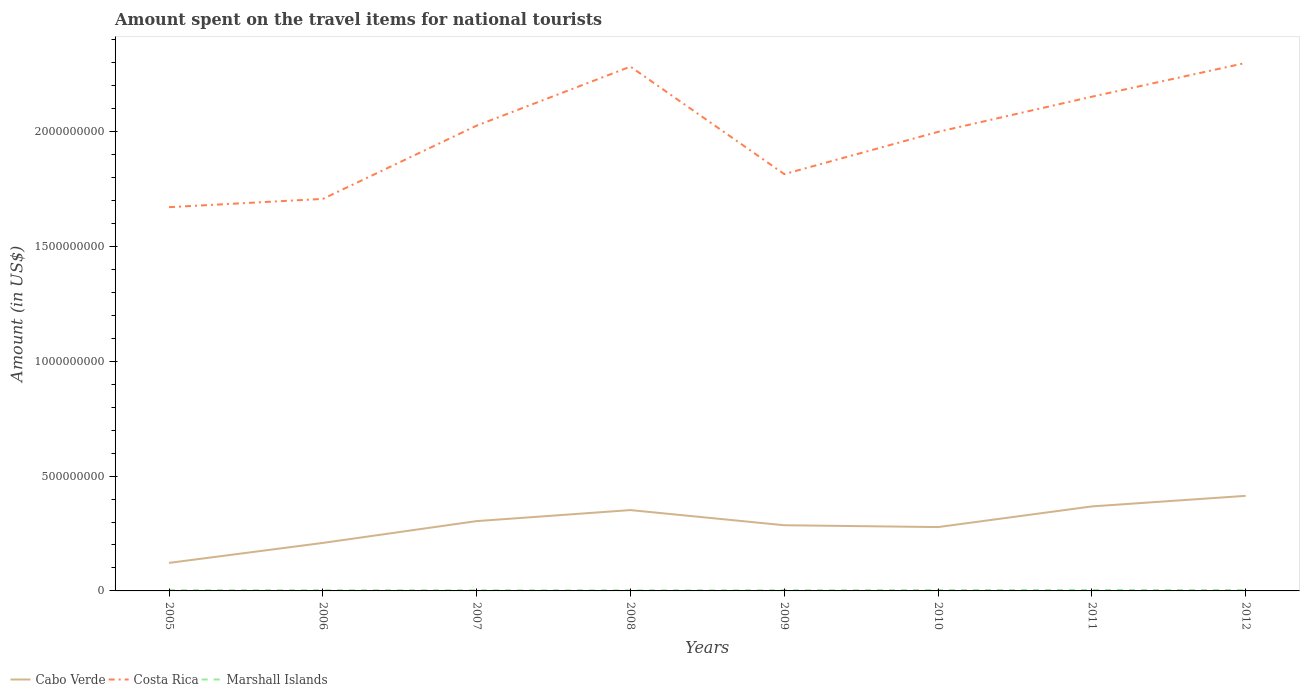How many different coloured lines are there?
Your response must be concise. 3. Across all years, what is the maximum amount spent on the travel items for national tourists in Cabo Verde?
Offer a terse response. 1.22e+08. In which year was the amount spent on the travel items for national tourists in Marshall Islands maximum?
Your response must be concise. 2008. What is the total amount spent on the travel items for national tourists in Costa Rica in the graph?
Provide a short and direct response. 4.68e+08. What is the difference between the highest and the second highest amount spent on the travel items for national tourists in Costa Rica?
Your answer should be very brief. 6.28e+08. What is the difference between the highest and the lowest amount spent on the travel items for national tourists in Cabo Verde?
Provide a short and direct response. 4. Is the amount spent on the travel items for national tourists in Marshall Islands strictly greater than the amount spent on the travel items for national tourists in Costa Rica over the years?
Keep it short and to the point. Yes. How many lines are there?
Give a very brief answer. 3. What is the difference between two consecutive major ticks on the Y-axis?
Offer a very short reply. 5.00e+08. Does the graph contain any zero values?
Provide a short and direct response. No. Does the graph contain grids?
Make the answer very short. No. What is the title of the graph?
Give a very brief answer. Amount spent on the travel items for national tourists. Does "Mongolia" appear as one of the legend labels in the graph?
Offer a very short reply. No. What is the label or title of the X-axis?
Offer a very short reply. Years. What is the label or title of the Y-axis?
Offer a terse response. Amount (in US$). What is the Amount (in US$) in Cabo Verde in 2005?
Keep it short and to the point. 1.22e+08. What is the Amount (in US$) of Costa Rica in 2005?
Offer a very short reply. 1.67e+09. What is the Amount (in US$) in Marshall Islands in 2005?
Offer a terse response. 3.20e+06. What is the Amount (in US$) of Cabo Verde in 2006?
Provide a succinct answer. 2.09e+08. What is the Amount (in US$) in Costa Rica in 2006?
Your answer should be compact. 1.71e+09. What is the Amount (in US$) in Marshall Islands in 2006?
Your answer should be compact. 3.10e+06. What is the Amount (in US$) of Cabo Verde in 2007?
Your answer should be compact. 3.04e+08. What is the Amount (in US$) of Costa Rica in 2007?
Your answer should be very brief. 2.03e+09. What is the Amount (in US$) of Marshall Islands in 2007?
Ensure brevity in your answer.  2.88e+06. What is the Amount (in US$) of Cabo Verde in 2008?
Your answer should be very brief. 3.52e+08. What is the Amount (in US$) of Costa Rica in 2008?
Provide a short and direct response. 2.28e+09. What is the Amount (in US$) in Marshall Islands in 2008?
Your response must be concise. 2.60e+06. What is the Amount (in US$) of Cabo Verde in 2009?
Make the answer very short. 2.86e+08. What is the Amount (in US$) in Costa Rica in 2009?
Provide a short and direct response. 1.82e+09. What is the Amount (in US$) in Marshall Islands in 2009?
Your answer should be compact. 2.90e+06. What is the Amount (in US$) in Cabo Verde in 2010?
Your answer should be compact. 2.78e+08. What is the Amount (in US$) of Costa Rica in 2010?
Ensure brevity in your answer.  2.00e+09. What is the Amount (in US$) in Marshall Islands in 2010?
Provide a short and direct response. 3.70e+06. What is the Amount (in US$) in Cabo Verde in 2011?
Provide a short and direct response. 3.68e+08. What is the Amount (in US$) of Costa Rica in 2011?
Give a very brief answer. 2.15e+09. What is the Amount (in US$) of Marshall Islands in 2011?
Provide a short and direct response. 3.98e+06. What is the Amount (in US$) in Cabo Verde in 2012?
Ensure brevity in your answer.  4.14e+08. What is the Amount (in US$) in Costa Rica in 2012?
Provide a succinct answer. 2.30e+09. What is the Amount (in US$) of Marshall Islands in 2012?
Keep it short and to the point. 3.65e+06. Across all years, what is the maximum Amount (in US$) of Cabo Verde?
Ensure brevity in your answer.  4.14e+08. Across all years, what is the maximum Amount (in US$) of Costa Rica?
Give a very brief answer. 2.30e+09. Across all years, what is the maximum Amount (in US$) in Marshall Islands?
Keep it short and to the point. 3.98e+06. Across all years, what is the minimum Amount (in US$) in Cabo Verde?
Your answer should be very brief. 1.22e+08. Across all years, what is the minimum Amount (in US$) of Costa Rica?
Ensure brevity in your answer.  1.67e+09. Across all years, what is the minimum Amount (in US$) in Marshall Islands?
Make the answer very short. 2.60e+06. What is the total Amount (in US$) in Cabo Verde in the graph?
Make the answer very short. 2.33e+09. What is the total Amount (in US$) of Costa Rica in the graph?
Offer a very short reply. 1.60e+1. What is the total Amount (in US$) in Marshall Islands in the graph?
Your answer should be very brief. 2.60e+07. What is the difference between the Amount (in US$) of Cabo Verde in 2005 and that in 2006?
Keep it short and to the point. -8.70e+07. What is the difference between the Amount (in US$) of Costa Rica in 2005 and that in 2006?
Make the answer very short. -3.60e+07. What is the difference between the Amount (in US$) of Cabo Verde in 2005 and that in 2007?
Keep it short and to the point. -1.82e+08. What is the difference between the Amount (in US$) in Costa Rica in 2005 and that in 2007?
Keep it short and to the point. -3.55e+08. What is the difference between the Amount (in US$) in Cabo Verde in 2005 and that in 2008?
Give a very brief answer. -2.30e+08. What is the difference between the Amount (in US$) in Costa Rica in 2005 and that in 2008?
Your answer should be compact. -6.12e+08. What is the difference between the Amount (in US$) of Marshall Islands in 2005 and that in 2008?
Offer a terse response. 6.00e+05. What is the difference between the Amount (in US$) of Cabo Verde in 2005 and that in 2009?
Offer a very short reply. -1.64e+08. What is the difference between the Amount (in US$) of Costa Rica in 2005 and that in 2009?
Provide a succinct answer. -1.44e+08. What is the difference between the Amount (in US$) in Cabo Verde in 2005 and that in 2010?
Give a very brief answer. -1.56e+08. What is the difference between the Amount (in US$) in Costa Rica in 2005 and that in 2010?
Your answer should be very brief. -3.28e+08. What is the difference between the Amount (in US$) of Marshall Islands in 2005 and that in 2010?
Provide a short and direct response. -5.00e+05. What is the difference between the Amount (in US$) in Cabo Verde in 2005 and that in 2011?
Your response must be concise. -2.46e+08. What is the difference between the Amount (in US$) in Costa Rica in 2005 and that in 2011?
Give a very brief answer. -4.81e+08. What is the difference between the Amount (in US$) of Marshall Islands in 2005 and that in 2011?
Your answer should be compact. -7.80e+05. What is the difference between the Amount (in US$) of Cabo Verde in 2005 and that in 2012?
Your answer should be compact. -2.92e+08. What is the difference between the Amount (in US$) in Costa Rica in 2005 and that in 2012?
Give a very brief answer. -6.28e+08. What is the difference between the Amount (in US$) of Marshall Islands in 2005 and that in 2012?
Give a very brief answer. -4.50e+05. What is the difference between the Amount (in US$) of Cabo Verde in 2006 and that in 2007?
Provide a succinct answer. -9.50e+07. What is the difference between the Amount (in US$) in Costa Rica in 2006 and that in 2007?
Your answer should be very brief. -3.19e+08. What is the difference between the Amount (in US$) of Cabo Verde in 2006 and that in 2008?
Offer a terse response. -1.43e+08. What is the difference between the Amount (in US$) of Costa Rica in 2006 and that in 2008?
Offer a terse response. -5.76e+08. What is the difference between the Amount (in US$) of Cabo Verde in 2006 and that in 2009?
Give a very brief answer. -7.70e+07. What is the difference between the Amount (in US$) in Costa Rica in 2006 and that in 2009?
Offer a very short reply. -1.08e+08. What is the difference between the Amount (in US$) of Marshall Islands in 2006 and that in 2009?
Offer a terse response. 2.00e+05. What is the difference between the Amount (in US$) of Cabo Verde in 2006 and that in 2010?
Ensure brevity in your answer.  -6.90e+07. What is the difference between the Amount (in US$) in Costa Rica in 2006 and that in 2010?
Give a very brief answer. -2.92e+08. What is the difference between the Amount (in US$) of Marshall Islands in 2006 and that in 2010?
Your answer should be compact. -6.00e+05. What is the difference between the Amount (in US$) in Cabo Verde in 2006 and that in 2011?
Your answer should be compact. -1.59e+08. What is the difference between the Amount (in US$) in Costa Rica in 2006 and that in 2011?
Provide a short and direct response. -4.45e+08. What is the difference between the Amount (in US$) in Marshall Islands in 2006 and that in 2011?
Your answer should be very brief. -8.80e+05. What is the difference between the Amount (in US$) of Cabo Verde in 2006 and that in 2012?
Offer a terse response. -2.05e+08. What is the difference between the Amount (in US$) of Costa Rica in 2006 and that in 2012?
Your answer should be very brief. -5.92e+08. What is the difference between the Amount (in US$) of Marshall Islands in 2006 and that in 2012?
Give a very brief answer. -5.50e+05. What is the difference between the Amount (in US$) of Cabo Verde in 2007 and that in 2008?
Offer a very short reply. -4.80e+07. What is the difference between the Amount (in US$) of Costa Rica in 2007 and that in 2008?
Provide a short and direct response. -2.57e+08. What is the difference between the Amount (in US$) of Marshall Islands in 2007 and that in 2008?
Offer a terse response. 2.80e+05. What is the difference between the Amount (in US$) of Cabo Verde in 2007 and that in 2009?
Give a very brief answer. 1.80e+07. What is the difference between the Amount (in US$) in Costa Rica in 2007 and that in 2009?
Your answer should be very brief. 2.11e+08. What is the difference between the Amount (in US$) of Marshall Islands in 2007 and that in 2009?
Ensure brevity in your answer.  -2.00e+04. What is the difference between the Amount (in US$) of Cabo Verde in 2007 and that in 2010?
Your response must be concise. 2.60e+07. What is the difference between the Amount (in US$) in Costa Rica in 2007 and that in 2010?
Offer a very short reply. 2.70e+07. What is the difference between the Amount (in US$) of Marshall Islands in 2007 and that in 2010?
Keep it short and to the point. -8.20e+05. What is the difference between the Amount (in US$) in Cabo Verde in 2007 and that in 2011?
Your answer should be compact. -6.40e+07. What is the difference between the Amount (in US$) of Costa Rica in 2007 and that in 2011?
Ensure brevity in your answer.  -1.26e+08. What is the difference between the Amount (in US$) of Marshall Islands in 2007 and that in 2011?
Make the answer very short. -1.10e+06. What is the difference between the Amount (in US$) of Cabo Verde in 2007 and that in 2012?
Your response must be concise. -1.10e+08. What is the difference between the Amount (in US$) in Costa Rica in 2007 and that in 2012?
Keep it short and to the point. -2.73e+08. What is the difference between the Amount (in US$) of Marshall Islands in 2007 and that in 2012?
Ensure brevity in your answer.  -7.70e+05. What is the difference between the Amount (in US$) of Cabo Verde in 2008 and that in 2009?
Provide a short and direct response. 6.60e+07. What is the difference between the Amount (in US$) of Costa Rica in 2008 and that in 2009?
Make the answer very short. 4.68e+08. What is the difference between the Amount (in US$) in Cabo Verde in 2008 and that in 2010?
Offer a terse response. 7.40e+07. What is the difference between the Amount (in US$) of Costa Rica in 2008 and that in 2010?
Your answer should be very brief. 2.84e+08. What is the difference between the Amount (in US$) of Marshall Islands in 2008 and that in 2010?
Make the answer very short. -1.10e+06. What is the difference between the Amount (in US$) of Cabo Verde in 2008 and that in 2011?
Ensure brevity in your answer.  -1.60e+07. What is the difference between the Amount (in US$) of Costa Rica in 2008 and that in 2011?
Offer a terse response. 1.31e+08. What is the difference between the Amount (in US$) of Marshall Islands in 2008 and that in 2011?
Your answer should be compact. -1.38e+06. What is the difference between the Amount (in US$) of Cabo Verde in 2008 and that in 2012?
Keep it short and to the point. -6.20e+07. What is the difference between the Amount (in US$) of Costa Rica in 2008 and that in 2012?
Ensure brevity in your answer.  -1.60e+07. What is the difference between the Amount (in US$) in Marshall Islands in 2008 and that in 2012?
Your answer should be compact. -1.05e+06. What is the difference between the Amount (in US$) in Costa Rica in 2009 and that in 2010?
Keep it short and to the point. -1.84e+08. What is the difference between the Amount (in US$) in Marshall Islands in 2009 and that in 2010?
Offer a terse response. -8.00e+05. What is the difference between the Amount (in US$) of Cabo Verde in 2009 and that in 2011?
Your answer should be compact. -8.20e+07. What is the difference between the Amount (in US$) in Costa Rica in 2009 and that in 2011?
Your response must be concise. -3.37e+08. What is the difference between the Amount (in US$) of Marshall Islands in 2009 and that in 2011?
Your answer should be compact. -1.08e+06. What is the difference between the Amount (in US$) of Cabo Verde in 2009 and that in 2012?
Provide a short and direct response. -1.28e+08. What is the difference between the Amount (in US$) of Costa Rica in 2009 and that in 2012?
Offer a very short reply. -4.84e+08. What is the difference between the Amount (in US$) in Marshall Islands in 2009 and that in 2012?
Give a very brief answer. -7.50e+05. What is the difference between the Amount (in US$) of Cabo Verde in 2010 and that in 2011?
Provide a short and direct response. -9.00e+07. What is the difference between the Amount (in US$) of Costa Rica in 2010 and that in 2011?
Keep it short and to the point. -1.53e+08. What is the difference between the Amount (in US$) of Marshall Islands in 2010 and that in 2011?
Offer a very short reply. -2.80e+05. What is the difference between the Amount (in US$) in Cabo Verde in 2010 and that in 2012?
Offer a very short reply. -1.36e+08. What is the difference between the Amount (in US$) in Costa Rica in 2010 and that in 2012?
Keep it short and to the point. -3.00e+08. What is the difference between the Amount (in US$) of Cabo Verde in 2011 and that in 2012?
Offer a very short reply. -4.60e+07. What is the difference between the Amount (in US$) of Costa Rica in 2011 and that in 2012?
Give a very brief answer. -1.47e+08. What is the difference between the Amount (in US$) of Marshall Islands in 2011 and that in 2012?
Keep it short and to the point. 3.30e+05. What is the difference between the Amount (in US$) of Cabo Verde in 2005 and the Amount (in US$) of Costa Rica in 2006?
Offer a terse response. -1.58e+09. What is the difference between the Amount (in US$) in Cabo Verde in 2005 and the Amount (in US$) in Marshall Islands in 2006?
Your response must be concise. 1.19e+08. What is the difference between the Amount (in US$) in Costa Rica in 2005 and the Amount (in US$) in Marshall Islands in 2006?
Your answer should be very brief. 1.67e+09. What is the difference between the Amount (in US$) of Cabo Verde in 2005 and the Amount (in US$) of Costa Rica in 2007?
Make the answer very short. -1.90e+09. What is the difference between the Amount (in US$) in Cabo Verde in 2005 and the Amount (in US$) in Marshall Islands in 2007?
Your response must be concise. 1.19e+08. What is the difference between the Amount (in US$) of Costa Rica in 2005 and the Amount (in US$) of Marshall Islands in 2007?
Ensure brevity in your answer.  1.67e+09. What is the difference between the Amount (in US$) in Cabo Verde in 2005 and the Amount (in US$) in Costa Rica in 2008?
Provide a succinct answer. -2.16e+09. What is the difference between the Amount (in US$) in Cabo Verde in 2005 and the Amount (in US$) in Marshall Islands in 2008?
Your response must be concise. 1.19e+08. What is the difference between the Amount (in US$) of Costa Rica in 2005 and the Amount (in US$) of Marshall Islands in 2008?
Offer a very short reply. 1.67e+09. What is the difference between the Amount (in US$) of Cabo Verde in 2005 and the Amount (in US$) of Costa Rica in 2009?
Your response must be concise. -1.69e+09. What is the difference between the Amount (in US$) of Cabo Verde in 2005 and the Amount (in US$) of Marshall Islands in 2009?
Ensure brevity in your answer.  1.19e+08. What is the difference between the Amount (in US$) in Costa Rica in 2005 and the Amount (in US$) in Marshall Islands in 2009?
Provide a succinct answer. 1.67e+09. What is the difference between the Amount (in US$) of Cabo Verde in 2005 and the Amount (in US$) of Costa Rica in 2010?
Your answer should be very brief. -1.88e+09. What is the difference between the Amount (in US$) in Cabo Verde in 2005 and the Amount (in US$) in Marshall Islands in 2010?
Ensure brevity in your answer.  1.18e+08. What is the difference between the Amount (in US$) in Costa Rica in 2005 and the Amount (in US$) in Marshall Islands in 2010?
Keep it short and to the point. 1.67e+09. What is the difference between the Amount (in US$) in Cabo Verde in 2005 and the Amount (in US$) in Costa Rica in 2011?
Provide a succinct answer. -2.03e+09. What is the difference between the Amount (in US$) in Cabo Verde in 2005 and the Amount (in US$) in Marshall Islands in 2011?
Offer a very short reply. 1.18e+08. What is the difference between the Amount (in US$) of Costa Rica in 2005 and the Amount (in US$) of Marshall Islands in 2011?
Your answer should be very brief. 1.67e+09. What is the difference between the Amount (in US$) of Cabo Verde in 2005 and the Amount (in US$) of Costa Rica in 2012?
Make the answer very short. -2.18e+09. What is the difference between the Amount (in US$) of Cabo Verde in 2005 and the Amount (in US$) of Marshall Islands in 2012?
Offer a terse response. 1.18e+08. What is the difference between the Amount (in US$) of Costa Rica in 2005 and the Amount (in US$) of Marshall Islands in 2012?
Keep it short and to the point. 1.67e+09. What is the difference between the Amount (in US$) in Cabo Verde in 2006 and the Amount (in US$) in Costa Rica in 2007?
Your answer should be compact. -1.82e+09. What is the difference between the Amount (in US$) of Cabo Verde in 2006 and the Amount (in US$) of Marshall Islands in 2007?
Your response must be concise. 2.06e+08. What is the difference between the Amount (in US$) of Costa Rica in 2006 and the Amount (in US$) of Marshall Islands in 2007?
Ensure brevity in your answer.  1.70e+09. What is the difference between the Amount (in US$) in Cabo Verde in 2006 and the Amount (in US$) in Costa Rica in 2008?
Give a very brief answer. -2.07e+09. What is the difference between the Amount (in US$) of Cabo Verde in 2006 and the Amount (in US$) of Marshall Islands in 2008?
Ensure brevity in your answer.  2.06e+08. What is the difference between the Amount (in US$) in Costa Rica in 2006 and the Amount (in US$) in Marshall Islands in 2008?
Keep it short and to the point. 1.70e+09. What is the difference between the Amount (in US$) of Cabo Verde in 2006 and the Amount (in US$) of Costa Rica in 2009?
Make the answer very short. -1.61e+09. What is the difference between the Amount (in US$) in Cabo Verde in 2006 and the Amount (in US$) in Marshall Islands in 2009?
Provide a short and direct response. 2.06e+08. What is the difference between the Amount (in US$) in Costa Rica in 2006 and the Amount (in US$) in Marshall Islands in 2009?
Provide a succinct answer. 1.70e+09. What is the difference between the Amount (in US$) in Cabo Verde in 2006 and the Amount (in US$) in Costa Rica in 2010?
Your response must be concise. -1.79e+09. What is the difference between the Amount (in US$) in Cabo Verde in 2006 and the Amount (in US$) in Marshall Islands in 2010?
Your answer should be compact. 2.05e+08. What is the difference between the Amount (in US$) of Costa Rica in 2006 and the Amount (in US$) of Marshall Islands in 2010?
Your response must be concise. 1.70e+09. What is the difference between the Amount (in US$) in Cabo Verde in 2006 and the Amount (in US$) in Costa Rica in 2011?
Keep it short and to the point. -1.94e+09. What is the difference between the Amount (in US$) in Cabo Verde in 2006 and the Amount (in US$) in Marshall Islands in 2011?
Your response must be concise. 2.05e+08. What is the difference between the Amount (in US$) of Costa Rica in 2006 and the Amount (in US$) of Marshall Islands in 2011?
Offer a terse response. 1.70e+09. What is the difference between the Amount (in US$) of Cabo Verde in 2006 and the Amount (in US$) of Costa Rica in 2012?
Ensure brevity in your answer.  -2.09e+09. What is the difference between the Amount (in US$) in Cabo Verde in 2006 and the Amount (in US$) in Marshall Islands in 2012?
Provide a short and direct response. 2.05e+08. What is the difference between the Amount (in US$) in Costa Rica in 2006 and the Amount (in US$) in Marshall Islands in 2012?
Keep it short and to the point. 1.70e+09. What is the difference between the Amount (in US$) of Cabo Verde in 2007 and the Amount (in US$) of Costa Rica in 2008?
Provide a succinct answer. -1.98e+09. What is the difference between the Amount (in US$) in Cabo Verde in 2007 and the Amount (in US$) in Marshall Islands in 2008?
Offer a very short reply. 3.01e+08. What is the difference between the Amount (in US$) in Costa Rica in 2007 and the Amount (in US$) in Marshall Islands in 2008?
Provide a short and direct response. 2.02e+09. What is the difference between the Amount (in US$) of Cabo Verde in 2007 and the Amount (in US$) of Costa Rica in 2009?
Your answer should be very brief. -1.51e+09. What is the difference between the Amount (in US$) in Cabo Verde in 2007 and the Amount (in US$) in Marshall Islands in 2009?
Keep it short and to the point. 3.01e+08. What is the difference between the Amount (in US$) of Costa Rica in 2007 and the Amount (in US$) of Marshall Islands in 2009?
Ensure brevity in your answer.  2.02e+09. What is the difference between the Amount (in US$) in Cabo Verde in 2007 and the Amount (in US$) in Costa Rica in 2010?
Ensure brevity in your answer.  -1.70e+09. What is the difference between the Amount (in US$) in Cabo Verde in 2007 and the Amount (in US$) in Marshall Islands in 2010?
Offer a very short reply. 3.00e+08. What is the difference between the Amount (in US$) of Costa Rica in 2007 and the Amount (in US$) of Marshall Islands in 2010?
Your response must be concise. 2.02e+09. What is the difference between the Amount (in US$) of Cabo Verde in 2007 and the Amount (in US$) of Costa Rica in 2011?
Offer a very short reply. -1.85e+09. What is the difference between the Amount (in US$) of Cabo Verde in 2007 and the Amount (in US$) of Marshall Islands in 2011?
Provide a succinct answer. 3.00e+08. What is the difference between the Amount (in US$) of Costa Rica in 2007 and the Amount (in US$) of Marshall Islands in 2011?
Offer a very short reply. 2.02e+09. What is the difference between the Amount (in US$) in Cabo Verde in 2007 and the Amount (in US$) in Costa Rica in 2012?
Offer a terse response. -2.00e+09. What is the difference between the Amount (in US$) of Cabo Verde in 2007 and the Amount (in US$) of Marshall Islands in 2012?
Make the answer very short. 3.00e+08. What is the difference between the Amount (in US$) of Costa Rica in 2007 and the Amount (in US$) of Marshall Islands in 2012?
Your answer should be very brief. 2.02e+09. What is the difference between the Amount (in US$) in Cabo Verde in 2008 and the Amount (in US$) in Costa Rica in 2009?
Your response must be concise. -1.46e+09. What is the difference between the Amount (in US$) in Cabo Verde in 2008 and the Amount (in US$) in Marshall Islands in 2009?
Provide a succinct answer. 3.49e+08. What is the difference between the Amount (in US$) in Costa Rica in 2008 and the Amount (in US$) in Marshall Islands in 2009?
Keep it short and to the point. 2.28e+09. What is the difference between the Amount (in US$) in Cabo Verde in 2008 and the Amount (in US$) in Costa Rica in 2010?
Your answer should be compact. -1.65e+09. What is the difference between the Amount (in US$) in Cabo Verde in 2008 and the Amount (in US$) in Marshall Islands in 2010?
Offer a very short reply. 3.48e+08. What is the difference between the Amount (in US$) in Costa Rica in 2008 and the Amount (in US$) in Marshall Islands in 2010?
Offer a terse response. 2.28e+09. What is the difference between the Amount (in US$) in Cabo Verde in 2008 and the Amount (in US$) in Costa Rica in 2011?
Offer a very short reply. -1.80e+09. What is the difference between the Amount (in US$) in Cabo Verde in 2008 and the Amount (in US$) in Marshall Islands in 2011?
Your answer should be compact. 3.48e+08. What is the difference between the Amount (in US$) of Costa Rica in 2008 and the Amount (in US$) of Marshall Islands in 2011?
Provide a short and direct response. 2.28e+09. What is the difference between the Amount (in US$) of Cabo Verde in 2008 and the Amount (in US$) of Costa Rica in 2012?
Provide a succinct answer. -1.95e+09. What is the difference between the Amount (in US$) in Cabo Verde in 2008 and the Amount (in US$) in Marshall Islands in 2012?
Your response must be concise. 3.48e+08. What is the difference between the Amount (in US$) in Costa Rica in 2008 and the Amount (in US$) in Marshall Islands in 2012?
Offer a very short reply. 2.28e+09. What is the difference between the Amount (in US$) in Cabo Verde in 2009 and the Amount (in US$) in Costa Rica in 2010?
Give a very brief answer. -1.71e+09. What is the difference between the Amount (in US$) of Cabo Verde in 2009 and the Amount (in US$) of Marshall Islands in 2010?
Offer a terse response. 2.82e+08. What is the difference between the Amount (in US$) of Costa Rica in 2009 and the Amount (in US$) of Marshall Islands in 2010?
Provide a short and direct response. 1.81e+09. What is the difference between the Amount (in US$) of Cabo Verde in 2009 and the Amount (in US$) of Costa Rica in 2011?
Your answer should be compact. -1.87e+09. What is the difference between the Amount (in US$) of Cabo Verde in 2009 and the Amount (in US$) of Marshall Islands in 2011?
Your answer should be compact. 2.82e+08. What is the difference between the Amount (in US$) of Costa Rica in 2009 and the Amount (in US$) of Marshall Islands in 2011?
Keep it short and to the point. 1.81e+09. What is the difference between the Amount (in US$) in Cabo Verde in 2009 and the Amount (in US$) in Costa Rica in 2012?
Your answer should be compact. -2.01e+09. What is the difference between the Amount (in US$) of Cabo Verde in 2009 and the Amount (in US$) of Marshall Islands in 2012?
Offer a very short reply. 2.82e+08. What is the difference between the Amount (in US$) in Costa Rica in 2009 and the Amount (in US$) in Marshall Islands in 2012?
Provide a short and direct response. 1.81e+09. What is the difference between the Amount (in US$) of Cabo Verde in 2010 and the Amount (in US$) of Costa Rica in 2011?
Offer a terse response. -1.87e+09. What is the difference between the Amount (in US$) in Cabo Verde in 2010 and the Amount (in US$) in Marshall Islands in 2011?
Keep it short and to the point. 2.74e+08. What is the difference between the Amount (in US$) of Costa Rica in 2010 and the Amount (in US$) of Marshall Islands in 2011?
Offer a terse response. 2.00e+09. What is the difference between the Amount (in US$) in Cabo Verde in 2010 and the Amount (in US$) in Costa Rica in 2012?
Ensure brevity in your answer.  -2.02e+09. What is the difference between the Amount (in US$) of Cabo Verde in 2010 and the Amount (in US$) of Marshall Islands in 2012?
Your response must be concise. 2.74e+08. What is the difference between the Amount (in US$) of Costa Rica in 2010 and the Amount (in US$) of Marshall Islands in 2012?
Your answer should be compact. 2.00e+09. What is the difference between the Amount (in US$) in Cabo Verde in 2011 and the Amount (in US$) in Costa Rica in 2012?
Keep it short and to the point. -1.93e+09. What is the difference between the Amount (in US$) of Cabo Verde in 2011 and the Amount (in US$) of Marshall Islands in 2012?
Keep it short and to the point. 3.64e+08. What is the difference between the Amount (in US$) of Costa Rica in 2011 and the Amount (in US$) of Marshall Islands in 2012?
Provide a short and direct response. 2.15e+09. What is the average Amount (in US$) of Cabo Verde per year?
Give a very brief answer. 2.92e+08. What is the average Amount (in US$) of Costa Rica per year?
Give a very brief answer. 1.99e+09. What is the average Amount (in US$) in Marshall Islands per year?
Keep it short and to the point. 3.25e+06. In the year 2005, what is the difference between the Amount (in US$) of Cabo Verde and Amount (in US$) of Costa Rica?
Provide a succinct answer. -1.55e+09. In the year 2005, what is the difference between the Amount (in US$) of Cabo Verde and Amount (in US$) of Marshall Islands?
Ensure brevity in your answer.  1.19e+08. In the year 2005, what is the difference between the Amount (in US$) of Costa Rica and Amount (in US$) of Marshall Islands?
Your answer should be compact. 1.67e+09. In the year 2006, what is the difference between the Amount (in US$) of Cabo Verde and Amount (in US$) of Costa Rica?
Your response must be concise. -1.50e+09. In the year 2006, what is the difference between the Amount (in US$) of Cabo Verde and Amount (in US$) of Marshall Islands?
Your answer should be compact. 2.06e+08. In the year 2006, what is the difference between the Amount (in US$) in Costa Rica and Amount (in US$) in Marshall Islands?
Give a very brief answer. 1.70e+09. In the year 2007, what is the difference between the Amount (in US$) in Cabo Verde and Amount (in US$) in Costa Rica?
Offer a very short reply. -1.72e+09. In the year 2007, what is the difference between the Amount (in US$) of Cabo Verde and Amount (in US$) of Marshall Islands?
Offer a terse response. 3.01e+08. In the year 2007, what is the difference between the Amount (in US$) in Costa Rica and Amount (in US$) in Marshall Islands?
Give a very brief answer. 2.02e+09. In the year 2008, what is the difference between the Amount (in US$) in Cabo Verde and Amount (in US$) in Costa Rica?
Offer a very short reply. -1.93e+09. In the year 2008, what is the difference between the Amount (in US$) in Cabo Verde and Amount (in US$) in Marshall Islands?
Ensure brevity in your answer.  3.49e+08. In the year 2008, what is the difference between the Amount (in US$) in Costa Rica and Amount (in US$) in Marshall Islands?
Keep it short and to the point. 2.28e+09. In the year 2009, what is the difference between the Amount (in US$) of Cabo Verde and Amount (in US$) of Costa Rica?
Make the answer very short. -1.53e+09. In the year 2009, what is the difference between the Amount (in US$) of Cabo Verde and Amount (in US$) of Marshall Islands?
Your answer should be compact. 2.83e+08. In the year 2009, what is the difference between the Amount (in US$) of Costa Rica and Amount (in US$) of Marshall Islands?
Keep it short and to the point. 1.81e+09. In the year 2010, what is the difference between the Amount (in US$) in Cabo Verde and Amount (in US$) in Costa Rica?
Your answer should be compact. -1.72e+09. In the year 2010, what is the difference between the Amount (in US$) of Cabo Verde and Amount (in US$) of Marshall Islands?
Provide a succinct answer. 2.74e+08. In the year 2010, what is the difference between the Amount (in US$) of Costa Rica and Amount (in US$) of Marshall Islands?
Provide a short and direct response. 2.00e+09. In the year 2011, what is the difference between the Amount (in US$) in Cabo Verde and Amount (in US$) in Costa Rica?
Provide a short and direct response. -1.78e+09. In the year 2011, what is the difference between the Amount (in US$) of Cabo Verde and Amount (in US$) of Marshall Islands?
Give a very brief answer. 3.64e+08. In the year 2011, what is the difference between the Amount (in US$) in Costa Rica and Amount (in US$) in Marshall Islands?
Make the answer very short. 2.15e+09. In the year 2012, what is the difference between the Amount (in US$) of Cabo Verde and Amount (in US$) of Costa Rica?
Provide a succinct answer. -1.88e+09. In the year 2012, what is the difference between the Amount (in US$) in Cabo Verde and Amount (in US$) in Marshall Islands?
Offer a terse response. 4.10e+08. In the year 2012, what is the difference between the Amount (in US$) of Costa Rica and Amount (in US$) of Marshall Islands?
Offer a very short reply. 2.30e+09. What is the ratio of the Amount (in US$) in Cabo Verde in 2005 to that in 2006?
Offer a very short reply. 0.58. What is the ratio of the Amount (in US$) in Costa Rica in 2005 to that in 2006?
Offer a very short reply. 0.98. What is the ratio of the Amount (in US$) in Marshall Islands in 2005 to that in 2006?
Make the answer very short. 1.03. What is the ratio of the Amount (in US$) in Cabo Verde in 2005 to that in 2007?
Your answer should be very brief. 0.4. What is the ratio of the Amount (in US$) in Costa Rica in 2005 to that in 2007?
Offer a very short reply. 0.82. What is the ratio of the Amount (in US$) of Cabo Verde in 2005 to that in 2008?
Give a very brief answer. 0.35. What is the ratio of the Amount (in US$) in Costa Rica in 2005 to that in 2008?
Ensure brevity in your answer.  0.73. What is the ratio of the Amount (in US$) of Marshall Islands in 2005 to that in 2008?
Offer a very short reply. 1.23. What is the ratio of the Amount (in US$) in Cabo Verde in 2005 to that in 2009?
Your answer should be compact. 0.43. What is the ratio of the Amount (in US$) of Costa Rica in 2005 to that in 2009?
Offer a very short reply. 0.92. What is the ratio of the Amount (in US$) in Marshall Islands in 2005 to that in 2009?
Offer a terse response. 1.1. What is the ratio of the Amount (in US$) in Cabo Verde in 2005 to that in 2010?
Provide a short and direct response. 0.44. What is the ratio of the Amount (in US$) of Costa Rica in 2005 to that in 2010?
Keep it short and to the point. 0.84. What is the ratio of the Amount (in US$) in Marshall Islands in 2005 to that in 2010?
Your response must be concise. 0.86. What is the ratio of the Amount (in US$) of Cabo Verde in 2005 to that in 2011?
Give a very brief answer. 0.33. What is the ratio of the Amount (in US$) of Costa Rica in 2005 to that in 2011?
Your response must be concise. 0.78. What is the ratio of the Amount (in US$) of Marshall Islands in 2005 to that in 2011?
Offer a very short reply. 0.8. What is the ratio of the Amount (in US$) in Cabo Verde in 2005 to that in 2012?
Ensure brevity in your answer.  0.29. What is the ratio of the Amount (in US$) of Costa Rica in 2005 to that in 2012?
Your answer should be compact. 0.73. What is the ratio of the Amount (in US$) of Marshall Islands in 2005 to that in 2012?
Provide a short and direct response. 0.88. What is the ratio of the Amount (in US$) in Cabo Verde in 2006 to that in 2007?
Offer a very short reply. 0.69. What is the ratio of the Amount (in US$) of Costa Rica in 2006 to that in 2007?
Ensure brevity in your answer.  0.84. What is the ratio of the Amount (in US$) in Marshall Islands in 2006 to that in 2007?
Offer a very short reply. 1.08. What is the ratio of the Amount (in US$) of Cabo Verde in 2006 to that in 2008?
Offer a very short reply. 0.59. What is the ratio of the Amount (in US$) of Costa Rica in 2006 to that in 2008?
Your response must be concise. 0.75. What is the ratio of the Amount (in US$) of Marshall Islands in 2006 to that in 2008?
Ensure brevity in your answer.  1.19. What is the ratio of the Amount (in US$) in Cabo Verde in 2006 to that in 2009?
Provide a short and direct response. 0.73. What is the ratio of the Amount (in US$) in Costa Rica in 2006 to that in 2009?
Offer a terse response. 0.94. What is the ratio of the Amount (in US$) of Marshall Islands in 2006 to that in 2009?
Your response must be concise. 1.07. What is the ratio of the Amount (in US$) of Cabo Verde in 2006 to that in 2010?
Your response must be concise. 0.75. What is the ratio of the Amount (in US$) of Costa Rica in 2006 to that in 2010?
Offer a very short reply. 0.85. What is the ratio of the Amount (in US$) in Marshall Islands in 2006 to that in 2010?
Make the answer very short. 0.84. What is the ratio of the Amount (in US$) in Cabo Verde in 2006 to that in 2011?
Give a very brief answer. 0.57. What is the ratio of the Amount (in US$) of Costa Rica in 2006 to that in 2011?
Your answer should be very brief. 0.79. What is the ratio of the Amount (in US$) of Marshall Islands in 2006 to that in 2011?
Offer a terse response. 0.78. What is the ratio of the Amount (in US$) in Cabo Verde in 2006 to that in 2012?
Ensure brevity in your answer.  0.5. What is the ratio of the Amount (in US$) in Costa Rica in 2006 to that in 2012?
Give a very brief answer. 0.74. What is the ratio of the Amount (in US$) in Marshall Islands in 2006 to that in 2012?
Offer a very short reply. 0.85. What is the ratio of the Amount (in US$) in Cabo Verde in 2007 to that in 2008?
Make the answer very short. 0.86. What is the ratio of the Amount (in US$) in Costa Rica in 2007 to that in 2008?
Keep it short and to the point. 0.89. What is the ratio of the Amount (in US$) of Marshall Islands in 2007 to that in 2008?
Ensure brevity in your answer.  1.11. What is the ratio of the Amount (in US$) in Cabo Verde in 2007 to that in 2009?
Give a very brief answer. 1.06. What is the ratio of the Amount (in US$) in Costa Rica in 2007 to that in 2009?
Your response must be concise. 1.12. What is the ratio of the Amount (in US$) of Cabo Verde in 2007 to that in 2010?
Give a very brief answer. 1.09. What is the ratio of the Amount (in US$) of Costa Rica in 2007 to that in 2010?
Provide a short and direct response. 1.01. What is the ratio of the Amount (in US$) in Marshall Islands in 2007 to that in 2010?
Offer a terse response. 0.78. What is the ratio of the Amount (in US$) of Cabo Verde in 2007 to that in 2011?
Provide a short and direct response. 0.83. What is the ratio of the Amount (in US$) of Costa Rica in 2007 to that in 2011?
Offer a terse response. 0.94. What is the ratio of the Amount (in US$) of Marshall Islands in 2007 to that in 2011?
Your response must be concise. 0.72. What is the ratio of the Amount (in US$) of Cabo Verde in 2007 to that in 2012?
Provide a short and direct response. 0.73. What is the ratio of the Amount (in US$) of Costa Rica in 2007 to that in 2012?
Offer a terse response. 0.88. What is the ratio of the Amount (in US$) in Marshall Islands in 2007 to that in 2012?
Your answer should be compact. 0.79. What is the ratio of the Amount (in US$) of Cabo Verde in 2008 to that in 2009?
Your response must be concise. 1.23. What is the ratio of the Amount (in US$) of Costa Rica in 2008 to that in 2009?
Make the answer very short. 1.26. What is the ratio of the Amount (in US$) in Marshall Islands in 2008 to that in 2009?
Give a very brief answer. 0.9. What is the ratio of the Amount (in US$) of Cabo Verde in 2008 to that in 2010?
Offer a terse response. 1.27. What is the ratio of the Amount (in US$) in Costa Rica in 2008 to that in 2010?
Keep it short and to the point. 1.14. What is the ratio of the Amount (in US$) of Marshall Islands in 2008 to that in 2010?
Keep it short and to the point. 0.7. What is the ratio of the Amount (in US$) in Cabo Verde in 2008 to that in 2011?
Keep it short and to the point. 0.96. What is the ratio of the Amount (in US$) in Costa Rica in 2008 to that in 2011?
Make the answer very short. 1.06. What is the ratio of the Amount (in US$) in Marshall Islands in 2008 to that in 2011?
Give a very brief answer. 0.65. What is the ratio of the Amount (in US$) in Cabo Verde in 2008 to that in 2012?
Offer a terse response. 0.85. What is the ratio of the Amount (in US$) of Marshall Islands in 2008 to that in 2012?
Offer a very short reply. 0.71. What is the ratio of the Amount (in US$) in Cabo Verde in 2009 to that in 2010?
Provide a succinct answer. 1.03. What is the ratio of the Amount (in US$) in Costa Rica in 2009 to that in 2010?
Provide a succinct answer. 0.91. What is the ratio of the Amount (in US$) in Marshall Islands in 2009 to that in 2010?
Give a very brief answer. 0.78. What is the ratio of the Amount (in US$) in Cabo Verde in 2009 to that in 2011?
Ensure brevity in your answer.  0.78. What is the ratio of the Amount (in US$) of Costa Rica in 2009 to that in 2011?
Provide a short and direct response. 0.84. What is the ratio of the Amount (in US$) of Marshall Islands in 2009 to that in 2011?
Your response must be concise. 0.73. What is the ratio of the Amount (in US$) of Cabo Verde in 2009 to that in 2012?
Your answer should be compact. 0.69. What is the ratio of the Amount (in US$) of Costa Rica in 2009 to that in 2012?
Give a very brief answer. 0.79. What is the ratio of the Amount (in US$) in Marshall Islands in 2009 to that in 2012?
Provide a short and direct response. 0.79. What is the ratio of the Amount (in US$) of Cabo Verde in 2010 to that in 2011?
Make the answer very short. 0.76. What is the ratio of the Amount (in US$) in Costa Rica in 2010 to that in 2011?
Keep it short and to the point. 0.93. What is the ratio of the Amount (in US$) of Marshall Islands in 2010 to that in 2011?
Ensure brevity in your answer.  0.93. What is the ratio of the Amount (in US$) in Cabo Verde in 2010 to that in 2012?
Your response must be concise. 0.67. What is the ratio of the Amount (in US$) of Costa Rica in 2010 to that in 2012?
Provide a succinct answer. 0.87. What is the ratio of the Amount (in US$) in Marshall Islands in 2010 to that in 2012?
Your answer should be very brief. 1.01. What is the ratio of the Amount (in US$) of Cabo Verde in 2011 to that in 2012?
Your answer should be compact. 0.89. What is the ratio of the Amount (in US$) in Costa Rica in 2011 to that in 2012?
Your answer should be compact. 0.94. What is the ratio of the Amount (in US$) in Marshall Islands in 2011 to that in 2012?
Ensure brevity in your answer.  1.09. What is the difference between the highest and the second highest Amount (in US$) of Cabo Verde?
Offer a terse response. 4.60e+07. What is the difference between the highest and the second highest Amount (in US$) in Costa Rica?
Your response must be concise. 1.60e+07. What is the difference between the highest and the second highest Amount (in US$) in Marshall Islands?
Your answer should be very brief. 2.80e+05. What is the difference between the highest and the lowest Amount (in US$) of Cabo Verde?
Offer a terse response. 2.92e+08. What is the difference between the highest and the lowest Amount (in US$) in Costa Rica?
Keep it short and to the point. 6.28e+08. What is the difference between the highest and the lowest Amount (in US$) in Marshall Islands?
Ensure brevity in your answer.  1.38e+06. 